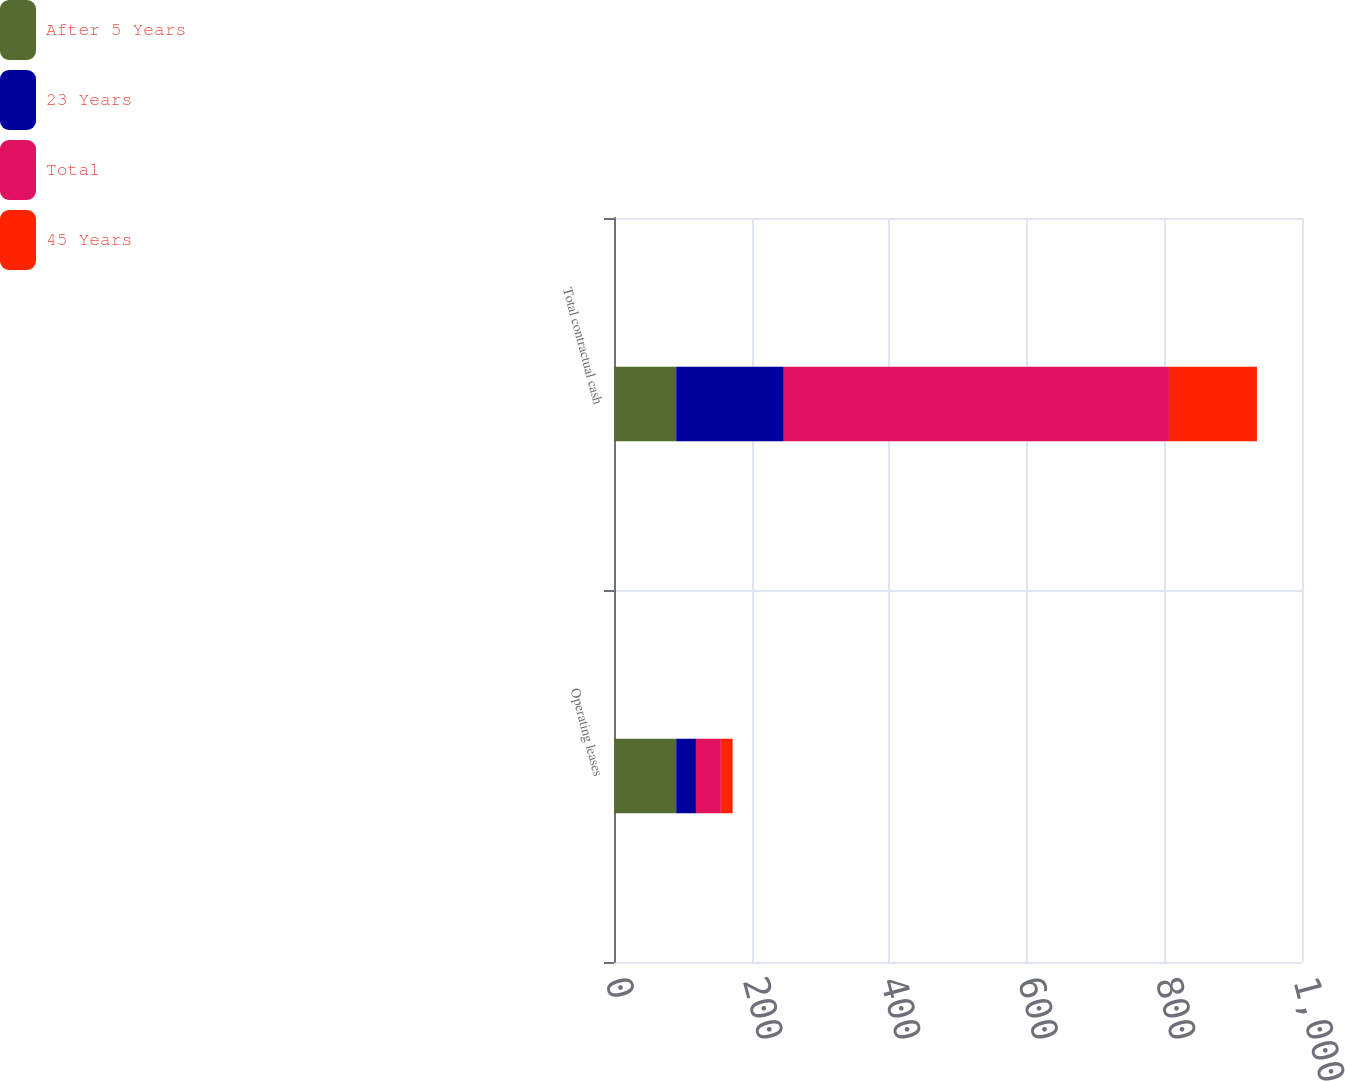<chart> <loc_0><loc_0><loc_500><loc_500><stacked_bar_chart><ecel><fcel>Operating leases<fcel>Total contractual cash<nl><fcel>After 5 Years<fcel>90.4<fcel>90.4<nl><fcel>23 Years<fcel>28.7<fcel>156.4<nl><fcel>Total<fcel>36.2<fcel>559.8<nl><fcel>45 Years<fcel>17.1<fcel>127.9<nl></chart> 